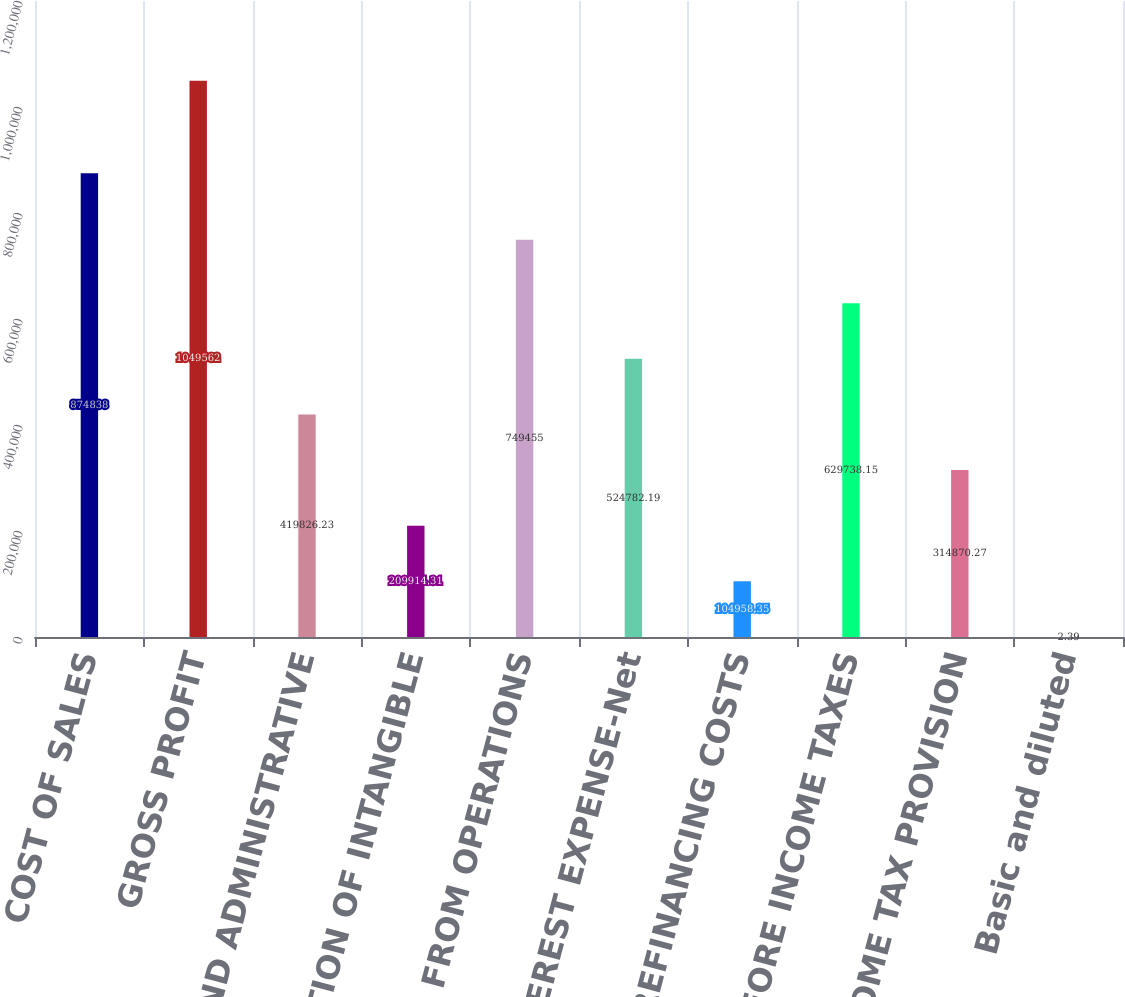<chart> <loc_0><loc_0><loc_500><loc_500><bar_chart><fcel>COST OF SALES<fcel>GROSS PROFIT<fcel>SELLING AND ADMINISTRATIVE<fcel>AMORTIZATION OF INTANGIBLE<fcel>INCOME FROM OPERATIONS<fcel>INTEREST EXPENSE-Net<fcel>REFINANCING COSTS<fcel>INCOME BEFORE INCOME TAXES<fcel>INCOME TAX PROVISION<fcel>Basic and diluted<nl><fcel>874838<fcel>1.04956e+06<fcel>419826<fcel>209914<fcel>749455<fcel>524782<fcel>104958<fcel>629738<fcel>314870<fcel>2.39<nl></chart> 